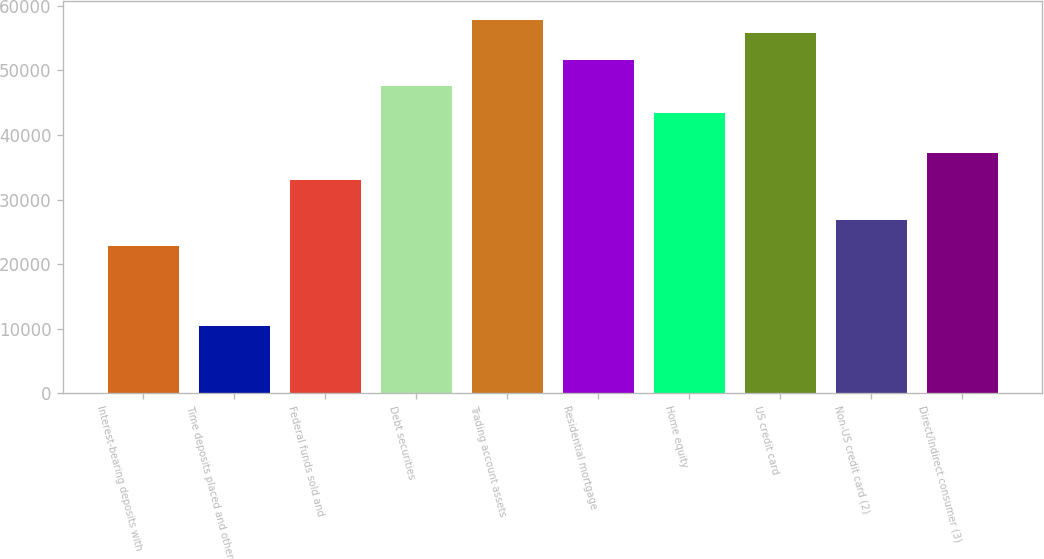Convert chart. <chart><loc_0><loc_0><loc_500><loc_500><bar_chart><fcel>Interest-bearing deposits with<fcel>Time deposits placed and other<fcel>Federal funds sold and<fcel>Debt securities<fcel>Trading account assets<fcel>Residential mortgage<fcel>Home equity<fcel>US credit card<fcel>Non-US credit card (2)<fcel>Direct/Indirect consumer (3)<nl><fcel>22734.3<fcel>10336.5<fcel>33065.8<fcel>47529.9<fcel>57861.4<fcel>51662.5<fcel>43397.3<fcel>55795.1<fcel>26866.9<fcel>37198.4<nl></chart> 